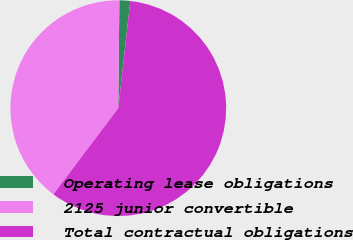Convert chart to OTSL. <chart><loc_0><loc_0><loc_500><loc_500><pie_chart><fcel>Operating lease obligations<fcel>2125 junior convertible<fcel>Total contractual obligations<nl><fcel>1.62%<fcel>39.88%<fcel>58.5%<nl></chart> 